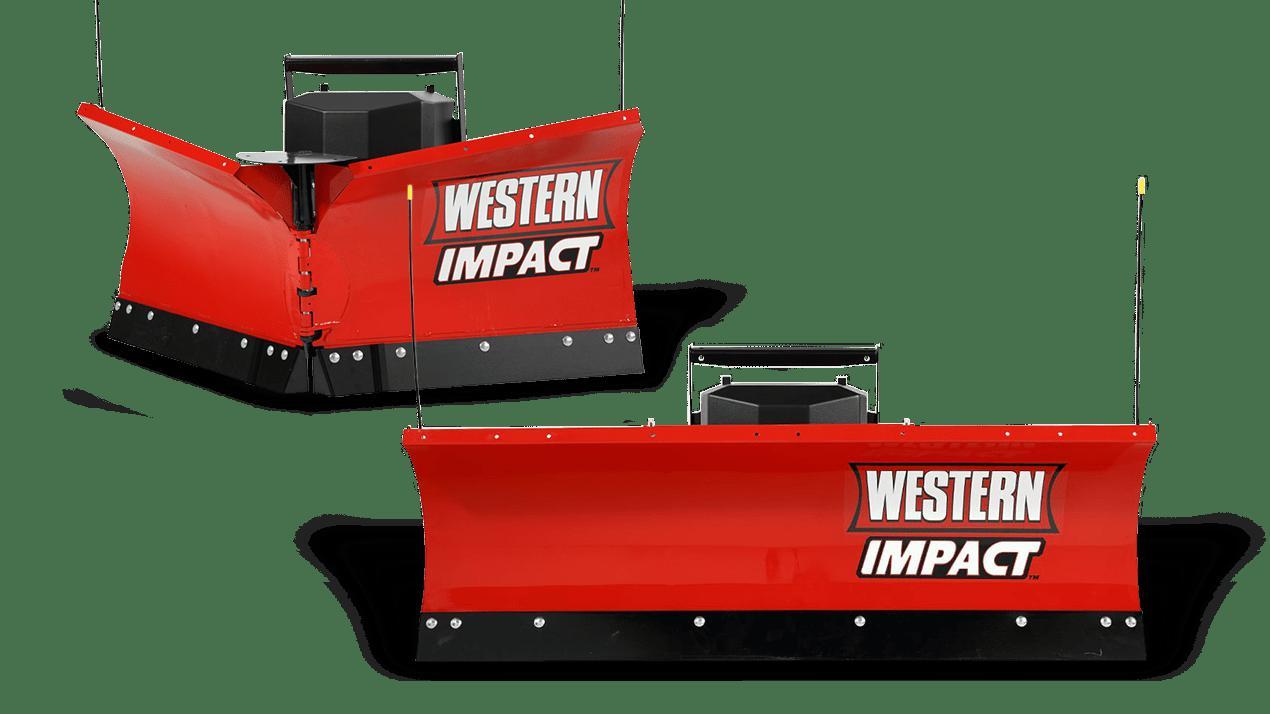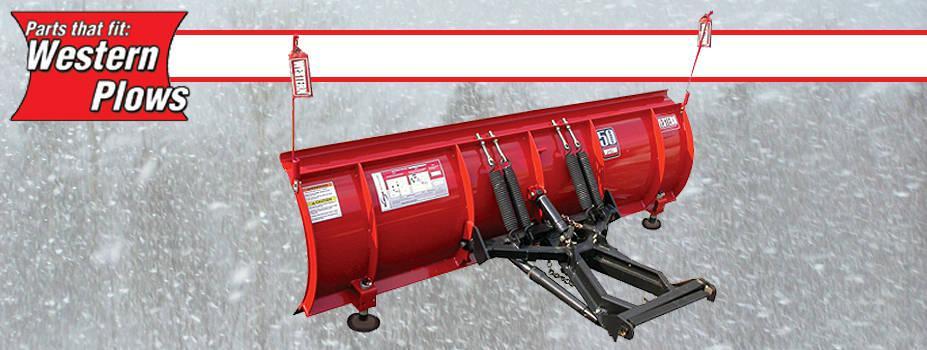The first image is the image on the left, the second image is the image on the right. Examine the images to the left and right. Is the description "In each image, a snow plow blade is shown with a pickup truck." accurate? Answer yes or no. No. 